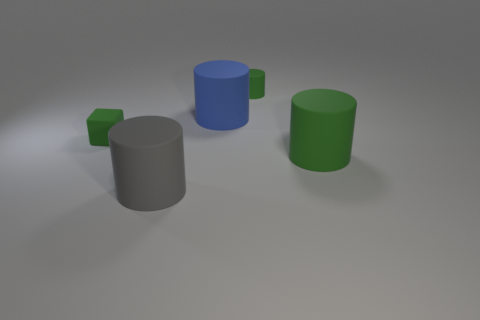There is a big cylinder in front of the big matte cylinder that is on the right side of the green rubber thing that is behind the small cube; what is its material?
Provide a short and direct response. Rubber. Does the tiny cube have the same color as the small cylinder?
Your answer should be compact. Yes. Are there any large cylinders that have the same color as the tiny rubber cylinder?
Offer a very short reply. Yes. There is a green thing that is the same size as the rubber block; what shape is it?
Ensure brevity in your answer.  Cylinder. Is the number of matte cylinders less than the number of blue rubber objects?
Make the answer very short. No. How many green things are the same size as the green cube?
Your response must be concise. 1. What is the shape of the tiny thing that is the same color as the tiny cube?
Ensure brevity in your answer.  Cylinder. What is the material of the small green cylinder?
Your answer should be compact. Rubber. What is the size of the green matte thing in front of the green cube?
Your response must be concise. Large. What number of tiny red shiny objects have the same shape as the blue object?
Offer a terse response. 0. 